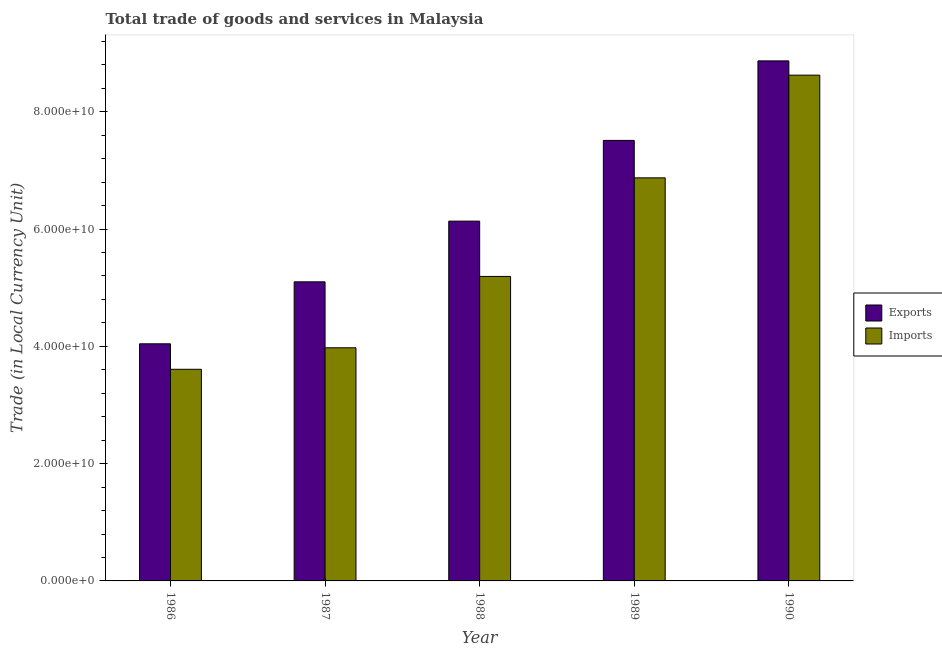How many groups of bars are there?
Give a very brief answer. 5. Are the number of bars per tick equal to the number of legend labels?
Offer a very short reply. Yes. How many bars are there on the 3rd tick from the left?
Make the answer very short. 2. In how many cases, is the number of bars for a given year not equal to the number of legend labels?
Offer a terse response. 0. What is the imports of goods and services in 1987?
Keep it short and to the point. 3.98e+1. Across all years, what is the maximum imports of goods and services?
Keep it short and to the point. 8.62e+1. Across all years, what is the minimum imports of goods and services?
Offer a very short reply. 3.61e+1. In which year was the imports of goods and services minimum?
Provide a short and direct response. 1986. What is the total export of goods and services in the graph?
Provide a short and direct response. 3.17e+11. What is the difference between the imports of goods and services in 1986 and that in 1990?
Your answer should be compact. -5.02e+1. What is the difference between the export of goods and services in 1990 and the imports of goods and services in 1989?
Offer a terse response. 1.36e+1. What is the average imports of goods and services per year?
Give a very brief answer. 5.65e+1. In the year 1989, what is the difference between the export of goods and services and imports of goods and services?
Give a very brief answer. 0. In how many years, is the imports of goods and services greater than 16000000000 LCU?
Provide a succinct answer. 5. What is the ratio of the imports of goods and services in 1986 to that in 1990?
Ensure brevity in your answer.  0.42. Is the imports of goods and services in 1987 less than that in 1989?
Make the answer very short. Yes. Is the difference between the imports of goods and services in 1986 and 1990 greater than the difference between the export of goods and services in 1986 and 1990?
Offer a very short reply. No. What is the difference between the highest and the second highest imports of goods and services?
Your response must be concise. 1.75e+1. What is the difference between the highest and the lowest imports of goods and services?
Give a very brief answer. 5.02e+1. In how many years, is the export of goods and services greater than the average export of goods and services taken over all years?
Give a very brief answer. 2. What does the 2nd bar from the left in 1989 represents?
Make the answer very short. Imports. What does the 1st bar from the right in 1986 represents?
Your response must be concise. Imports. How many bars are there?
Give a very brief answer. 10. Are all the bars in the graph horizontal?
Your answer should be very brief. No. Are the values on the major ticks of Y-axis written in scientific E-notation?
Give a very brief answer. Yes. Does the graph contain any zero values?
Provide a succinct answer. No. Where does the legend appear in the graph?
Your answer should be very brief. Center right. How many legend labels are there?
Provide a succinct answer. 2. What is the title of the graph?
Offer a terse response. Total trade of goods and services in Malaysia. What is the label or title of the X-axis?
Give a very brief answer. Year. What is the label or title of the Y-axis?
Offer a very short reply. Trade (in Local Currency Unit). What is the Trade (in Local Currency Unit) of Exports in 1986?
Keep it short and to the point. 4.04e+1. What is the Trade (in Local Currency Unit) of Imports in 1986?
Provide a succinct answer. 3.61e+1. What is the Trade (in Local Currency Unit) of Exports in 1987?
Keep it short and to the point. 5.10e+1. What is the Trade (in Local Currency Unit) of Imports in 1987?
Your answer should be compact. 3.98e+1. What is the Trade (in Local Currency Unit) of Exports in 1988?
Offer a very short reply. 6.13e+1. What is the Trade (in Local Currency Unit) in Imports in 1988?
Provide a short and direct response. 5.19e+1. What is the Trade (in Local Currency Unit) in Exports in 1989?
Offer a terse response. 7.51e+1. What is the Trade (in Local Currency Unit) in Imports in 1989?
Make the answer very short. 6.87e+1. What is the Trade (in Local Currency Unit) of Exports in 1990?
Your answer should be compact. 8.87e+1. What is the Trade (in Local Currency Unit) in Imports in 1990?
Offer a terse response. 8.62e+1. Across all years, what is the maximum Trade (in Local Currency Unit) in Exports?
Provide a succinct answer. 8.87e+1. Across all years, what is the maximum Trade (in Local Currency Unit) of Imports?
Provide a succinct answer. 8.62e+1. Across all years, what is the minimum Trade (in Local Currency Unit) in Exports?
Give a very brief answer. 4.04e+1. Across all years, what is the minimum Trade (in Local Currency Unit) of Imports?
Provide a succinct answer. 3.61e+1. What is the total Trade (in Local Currency Unit) in Exports in the graph?
Ensure brevity in your answer.  3.17e+11. What is the total Trade (in Local Currency Unit) in Imports in the graph?
Your answer should be compact. 2.83e+11. What is the difference between the Trade (in Local Currency Unit) of Exports in 1986 and that in 1987?
Provide a succinct answer. -1.06e+1. What is the difference between the Trade (in Local Currency Unit) in Imports in 1986 and that in 1987?
Ensure brevity in your answer.  -3.67e+09. What is the difference between the Trade (in Local Currency Unit) in Exports in 1986 and that in 1988?
Offer a very short reply. -2.09e+1. What is the difference between the Trade (in Local Currency Unit) in Imports in 1986 and that in 1988?
Provide a short and direct response. -1.58e+1. What is the difference between the Trade (in Local Currency Unit) in Exports in 1986 and that in 1989?
Your answer should be compact. -3.47e+1. What is the difference between the Trade (in Local Currency Unit) in Imports in 1986 and that in 1989?
Ensure brevity in your answer.  -3.26e+1. What is the difference between the Trade (in Local Currency Unit) in Exports in 1986 and that in 1990?
Provide a succinct answer. -4.82e+1. What is the difference between the Trade (in Local Currency Unit) of Imports in 1986 and that in 1990?
Give a very brief answer. -5.02e+1. What is the difference between the Trade (in Local Currency Unit) of Exports in 1987 and that in 1988?
Your response must be concise. -1.03e+1. What is the difference between the Trade (in Local Currency Unit) of Imports in 1987 and that in 1988?
Provide a short and direct response. -1.22e+1. What is the difference between the Trade (in Local Currency Unit) of Exports in 1987 and that in 1989?
Your answer should be very brief. -2.41e+1. What is the difference between the Trade (in Local Currency Unit) in Imports in 1987 and that in 1989?
Offer a terse response. -2.90e+1. What is the difference between the Trade (in Local Currency Unit) of Exports in 1987 and that in 1990?
Make the answer very short. -3.77e+1. What is the difference between the Trade (in Local Currency Unit) in Imports in 1987 and that in 1990?
Give a very brief answer. -4.65e+1. What is the difference between the Trade (in Local Currency Unit) of Exports in 1988 and that in 1989?
Provide a succinct answer. -1.38e+1. What is the difference between the Trade (in Local Currency Unit) in Imports in 1988 and that in 1989?
Ensure brevity in your answer.  -1.68e+1. What is the difference between the Trade (in Local Currency Unit) of Exports in 1988 and that in 1990?
Ensure brevity in your answer.  -2.73e+1. What is the difference between the Trade (in Local Currency Unit) in Imports in 1988 and that in 1990?
Give a very brief answer. -3.43e+1. What is the difference between the Trade (in Local Currency Unit) of Exports in 1989 and that in 1990?
Provide a short and direct response. -1.36e+1. What is the difference between the Trade (in Local Currency Unit) in Imports in 1989 and that in 1990?
Your answer should be compact. -1.75e+1. What is the difference between the Trade (in Local Currency Unit) in Exports in 1986 and the Trade (in Local Currency Unit) in Imports in 1987?
Offer a terse response. 6.80e+08. What is the difference between the Trade (in Local Currency Unit) in Exports in 1986 and the Trade (in Local Currency Unit) in Imports in 1988?
Make the answer very short. -1.15e+1. What is the difference between the Trade (in Local Currency Unit) of Exports in 1986 and the Trade (in Local Currency Unit) of Imports in 1989?
Offer a terse response. -2.83e+1. What is the difference between the Trade (in Local Currency Unit) of Exports in 1986 and the Trade (in Local Currency Unit) of Imports in 1990?
Provide a succinct answer. -4.58e+1. What is the difference between the Trade (in Local Currency Unit) of Exports in 1987 and the Trade (in Local Currency Unit) of Imports in 1988?
Your response must be concise. -9.22e+08. What is the difference between the Trade (in Local Currency Unit) of Exports in 1987 and the Trade (in Local Currency Unit) of Imports in 1989?
Offer a terse response. -1.77e+1. What is the difference between the Trade (in Local Currency Unit) of Exports in 1987 and the Trade (in Local Currency Unit) of Imports in 1990?
Make the answer very short. -3.52e+1. What is the difference between the Trade (in Local Currency Unit) in Exports in 1988 and the Trade (in Local Currency Unit) in Imports in 1989?
Offer a very short reply. -7.38e+09. What is the difference between the Trade (in Local Currency Unit) of Exports in 1988 and the Trade (in Local Currency Unit) of Imports in 1990?
Offer a very short reply. -2.49e+1. What is the difference between the Trade (in Local Currency Unit) of Exports in 1989 and the Trade (in Local Currency Unit) of Imports in 1990?
Your response must be concise. -1.11e+1. What is the average Trade (in Local Currency Unit) of Exports per year?
Give a very brief answer. 6.33e+1. What is the average Trade (in Local Currency Unit) of Imports per year?
Give a very brief answer. 5.65e+1. In the year 1986, what is the difference between the Trade (in Local Currency Unit) in Exports and Trade (in Local Currency Unit) in Imports?
Make the answer very short. 4.35e+09. In the year 1987, what is the difference between the Trade (in Local Currency Unit) in Exports and Trade (in Local Currency Unit) in Imports?
Offer a very short reply. 1.12e+1. In the year 1988, what is the difference between the Trade (in Local Currency Unit) of Exports and Trade (in Local Currency Unit) of Imports?
Your answer should be compact. 9.43e+09. In the year 1989, what is the difference between the Trade (in Local Currency Unit) in Exports and Trade (in Local Currency Unit) in Imports?
Give a very brief answer. 6.38e+09. In the year 1990, what is the difference between the Trade (in Local Currency Unit) of Exports and Trade (in Local Currency Unit) of Imports?
Your answer should be very brief. 2.43e+09. What is the ratio of the Trade (in Local Currency Unit) in Exports in 1986 to that in 1987?
Your answer should be very brief. 0.79. What is the ratio of the Trade (in Local Currency Unit) of Imports in 1986 to that in 1987?
Your response must be concise. 0.91. What is the ratio of the Trade (in Local Currency Unit) in Exports in 1986 to that in 1988?
Offer a very short reply. 0.66. What is the ratio of the Trade (in Local Currency Unit) in Imports in 1986 to that in 1988?
Offer a terse response. 0.69. What is the ratio of the Trade (in Local Currency Unit) in Exports in 1986 to that in 1989?
Offer a terse response. 0.54. What is the ratio of the Trade (in Local Currency Unit) of Imports in 1986 to that in 1989?
Your response must be concise. 0.53. What is the ratio of the Trade (in Local Currency Unit) of Exports in 1986 to that in 1990?
Make the answer very short. 0.46. What is the ratio of the Trade (in Local Currency Unit) in Imports in 1986 to that in 1990?
Your answer should be very brief. 0.42. What is the ratio of the Trade (in Local Currency Unit) in Exports in 1987 to that in 1988?
Make the answer very short. 0.83. What is the ratio of the Trade (in Local Currency Unit) in Imports in 1987 to that in 1988?
Your answer should be very brief. 0.77. What is the ratio of the Trade (in Local Currency Unit) of Exports in 1987 to that in 1989?
Offer a terse response. 0.68. What is the ratio of the Trade (in Local Currency Unit) in Imports in 1987 to that in 1989?
Give a very brief answer. 0.58. What is the ratio of the Trade (in Local Currency Unit) in Exports in 1987 to that in 1990?
Your answer should be very brief. 0.58. What is the ratio of the Trade (in Local Currency Unit) in Imports in 1987 to that in 1990?
Your response must be concise. 0.46. What is the ratio of the Trade (in Local Currency Unit) in Exports in 1988 to that in 1989?
Keep it short and to the point. 0.82. What is the ratio of the Trade (in Local Currency Unit) in Imports in 1988 to that in 1989?
Provide a succinct answer. 0.76. What is the ratio of the Trade (in Local Currency Unit) of Exports in 1988 to that in 1990?
Offer a very short reply. 0.69. What is the ratio of the Trade (in Local Currency Unit) of Imports in 1988 to that in 1990?
Make the answer very short. 0.6. What is the ratio of the Trade (in Local Currency Unit) of Exports in 1989 to that in 1990?
Your answer should be compact. 0.85. What is the ratio of the Trade (in Local Currency Unit) in Imports in 1989 to that in 1990?
Offer a very short reply. 0.8. What is the difference between the highest and the second highest Trade (in Local Currency Unit) in Exports?
Your answer should be compact. 1.36e+1. What is the difference between the highest and the second highest Trade (in Local Currency Unit) of Imports?
Your answer should be compact. 1.75e+1. What is the difference between the highest and the lowest Trade (in Local Currency Unit) of Exports?
Offer a terse response. 4.82e+1. What is the difference between the highest and the lowest Trade (in Local Currency Unit) of Imports?
Offer a terse response. 5.02e+1. 